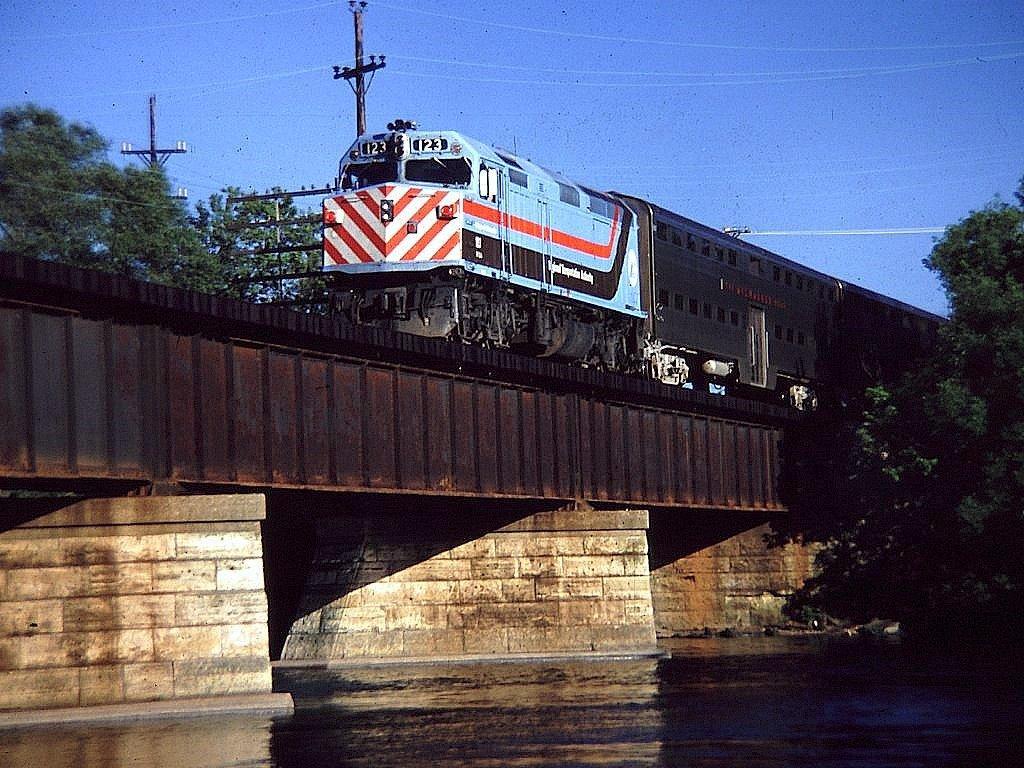Can you describe this image briefly? In this image I can see the water. I can see a train on the railway track. On the left and right side, I can see the trees. At the top I can see the electric poles and the sky. 